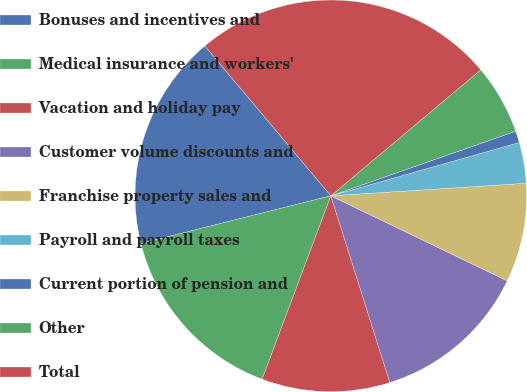<chart> <loc_0><loc_0><loc_500><loc_500><pie_chart><fcel>Bonuses and incentives and<fcel>Medical insurance and workers'<fcel>Vacation and holiday pay<fcel>Customer volume discounts and<fcel>Franchise property sales and<fcel>Payroll and payroll taxes<fcel>Current portion of pension and<fcel>Other<fcel>Total<nl><fcel>17.79%<fcel>15.38%<fcel>10.58%<fcel>12.98%<fcel>8.17%<fcel>3.37%<fcel>0.96%<fcel>5.77%<fcel>25.0%<nl></chart> 